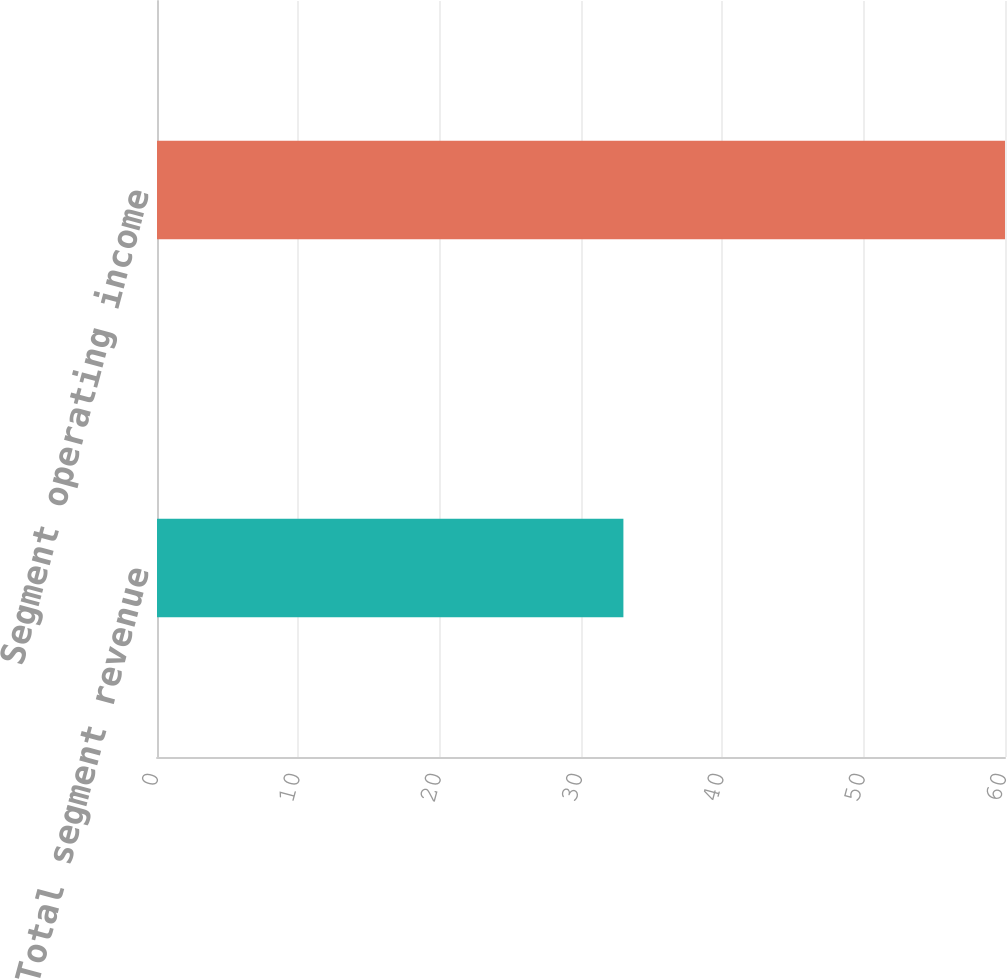Convert chart to OTSL. <chart><loc_0><loc_0><loc_500><loc_500><bar_chart><fcel>Total segment revenue<fcel>Segment operating income<nl><fcel>33<fcel>60<nl></chart> 